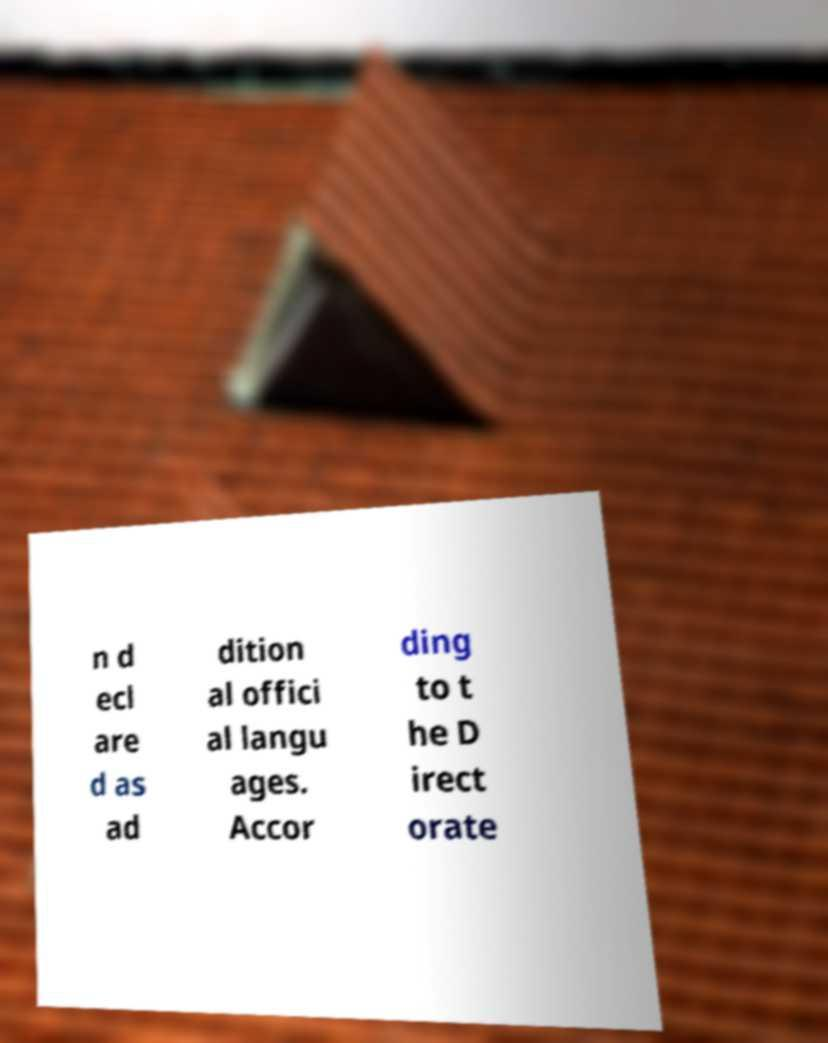Could you assist in decoding the text presented in this image and type it out clearly? n d ecl are d as ad dition al offici al langu ages. Accor ding to t he D irect orate 